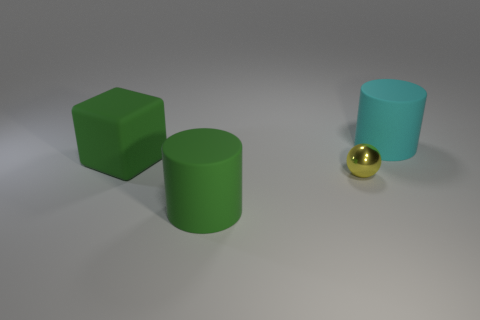Subtract all red blocks. How many green cylinders are left? 1 Add 1 big rubber objects. How many objects exist? 5 Subtract 1 cylinders. How many cylinders are left? 1 Subtract all small red cylinders. Subtract all tiny balls. How many objects are left? 3 Add 1 yellow spheres. How many yellow spheres are left? 2 Add 2 big cyan rubber cylinders. How many big cyan rubber cylinders exist? 3 Subtract 0 gray cylinders. How many objects are left? 4 Subtract all spheres. How many objects are left? 3 Subtract all cyan cylinders. Subtract all green spheres. How many cylinders are left? 1 